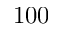Convert formula to latex. <formula><loc_0><loc_0><loc_500><loc_500>1 0 0</formula> 